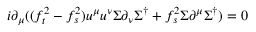Convert formula to latex. <formula><loc_0><loc_0><loc_500><loc_500>i \partial _ { \mu } ( ( f _ { t } ^ { 2 } - f _ { s } ^ { 2 } ) u ^ { \mu } u ^ { \nu } \Sigma \partial _ { \nu } \Sigma ^ { \dagger } + f _ { s } ^ { 2 } \Sigma \partial ^ { \mu } \Sigma ^ { \dagger } ) = 0</formula> 